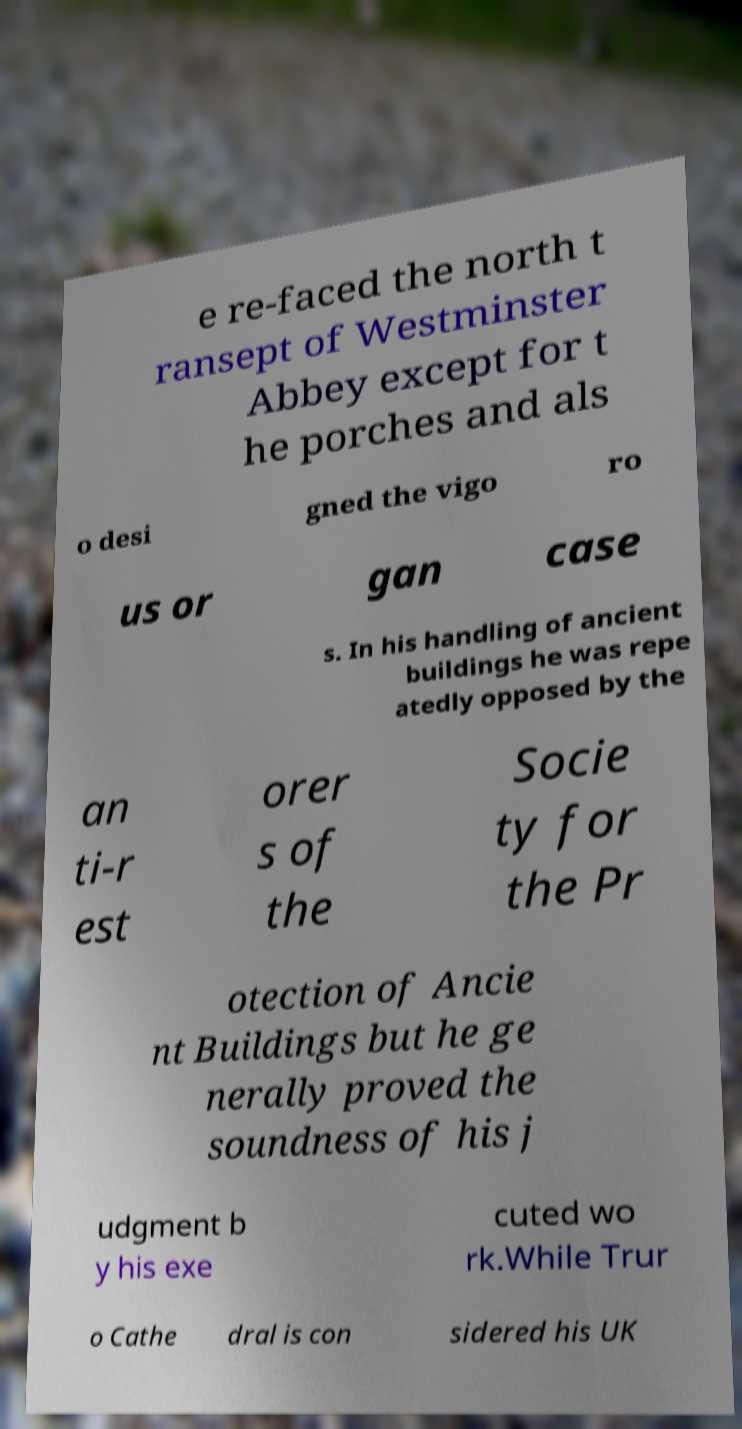Could you assist in decoding the text presented in this image and type it out clearly? e re-faced the north t ransept of Westminster Abbey except for t he porches and als o desi gned the vigo ro us or gan case s. In his handling of ancient buildings he was repe atedly opposed by the an ti-r est orer s of the Socie ty for the Pr otection of Ancie nt Buildings but he ge nerally proved the soundness of his j udgment b y his exe cuted wo rk.While Trur o Cathe dral is con sidered his UK 